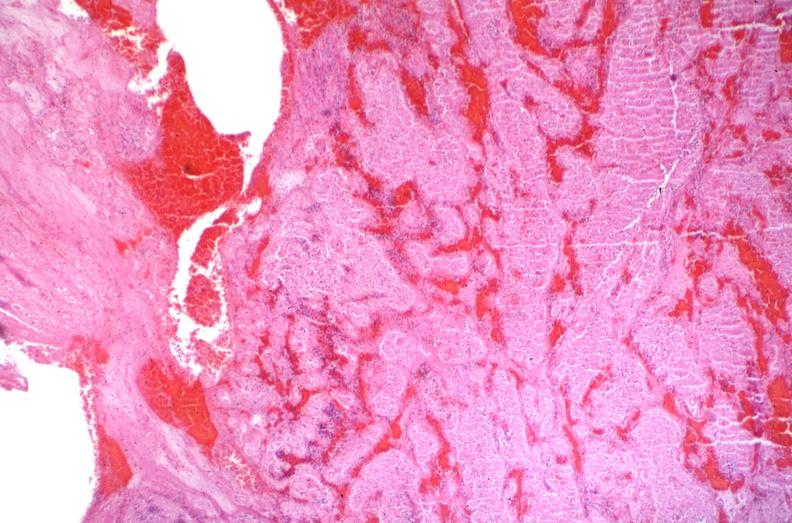s this section present?
Answer the question using a single word or phrase. No 